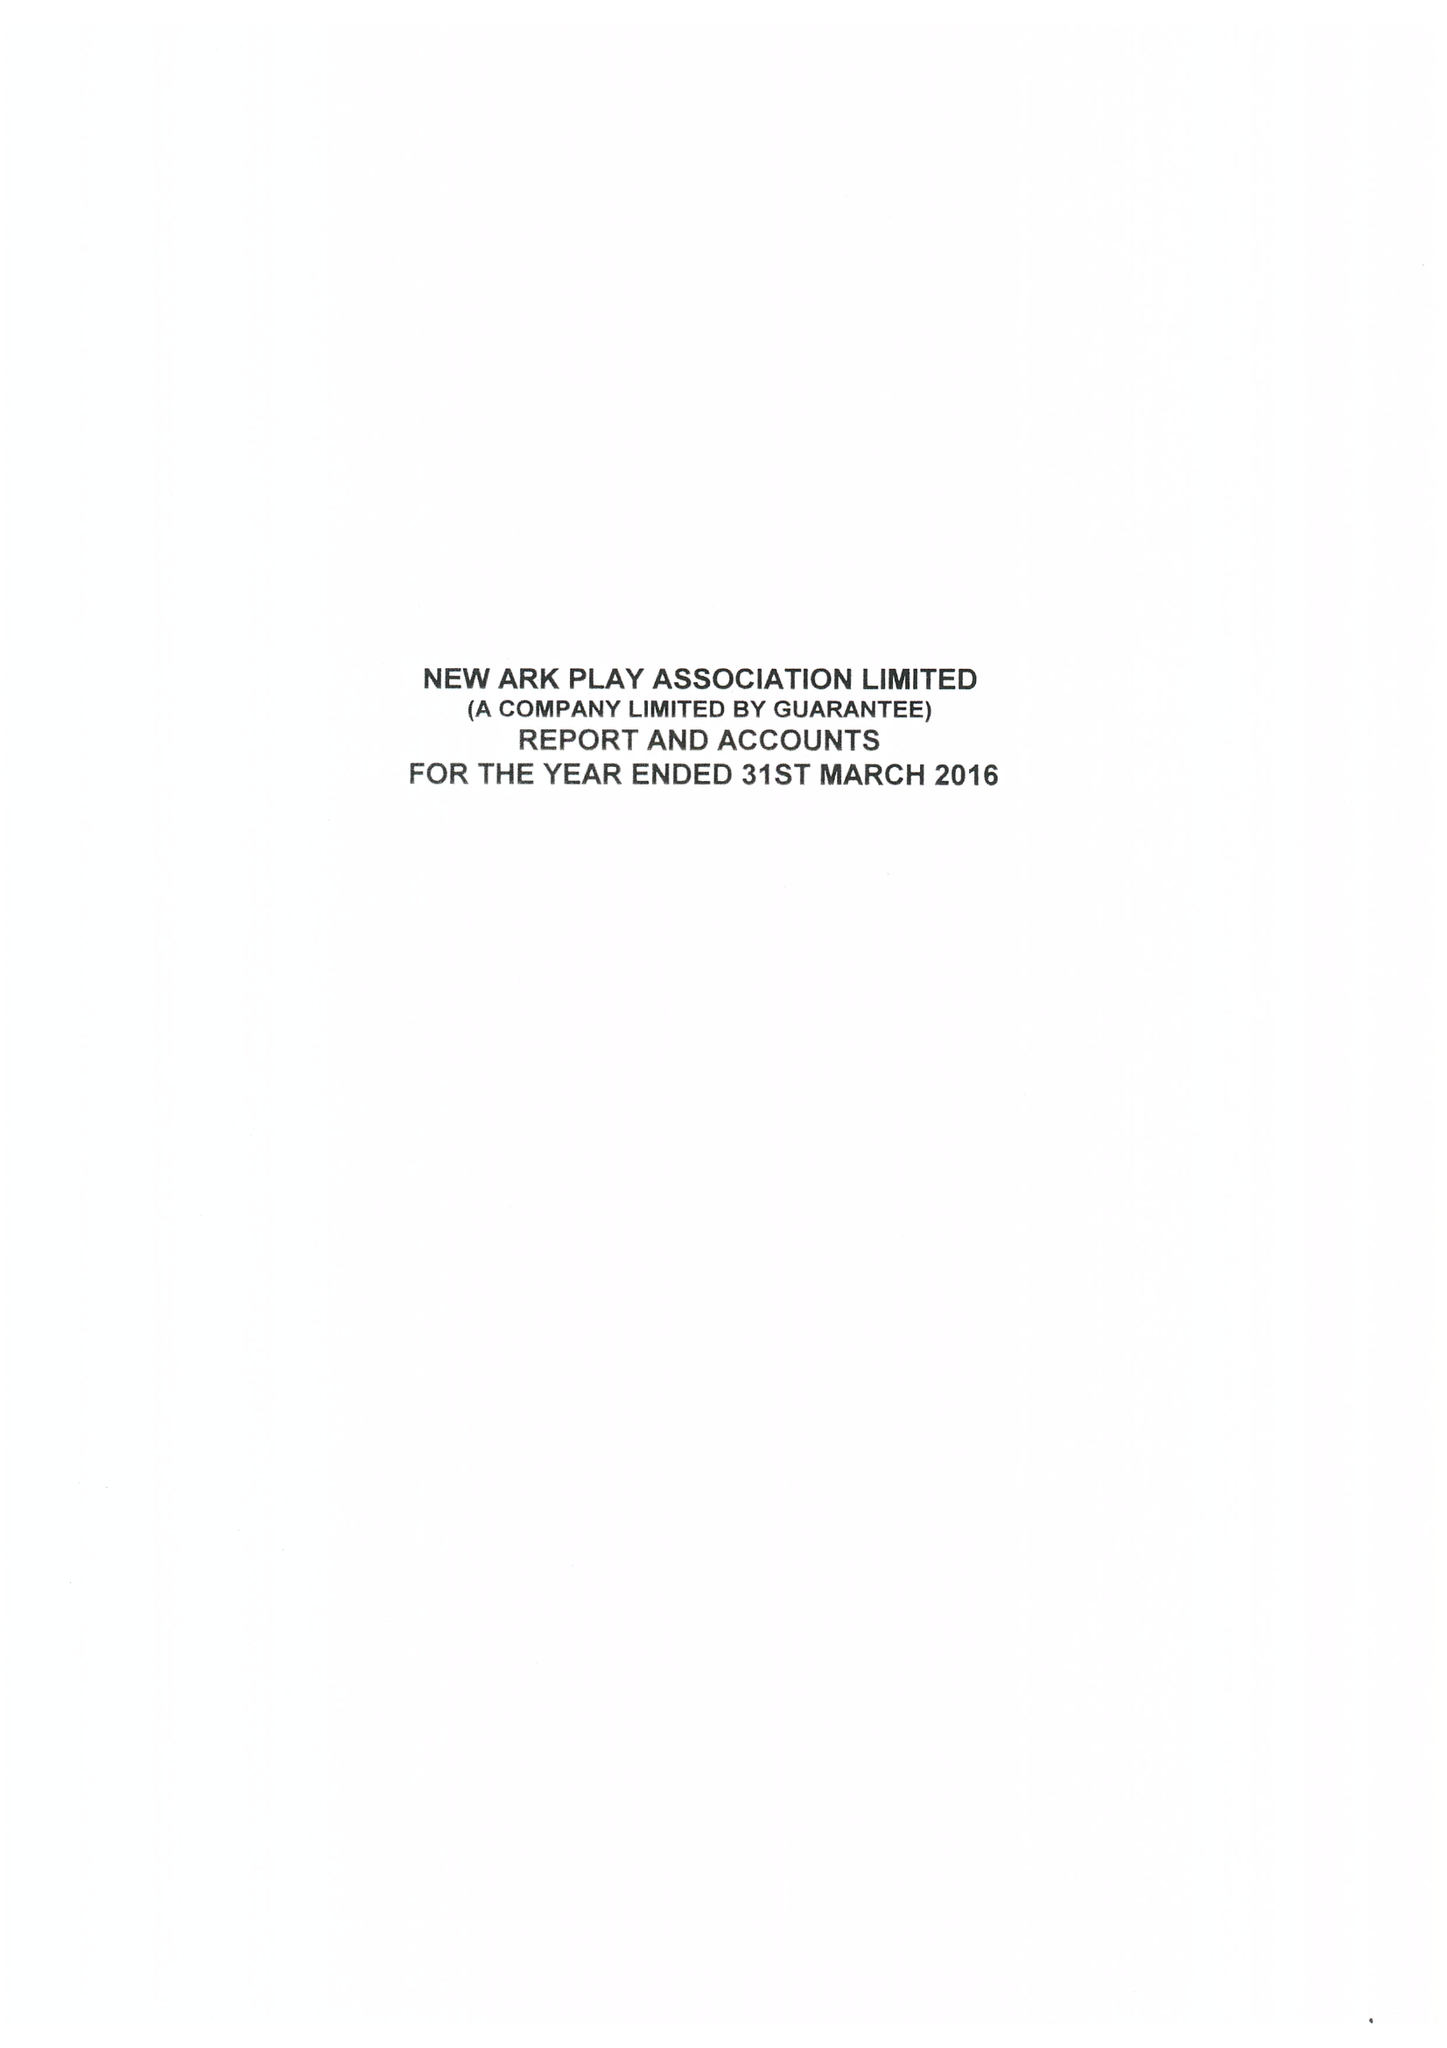What is the value for the report_date?
Answer the question using a single word or phrase. 2016-03-31 